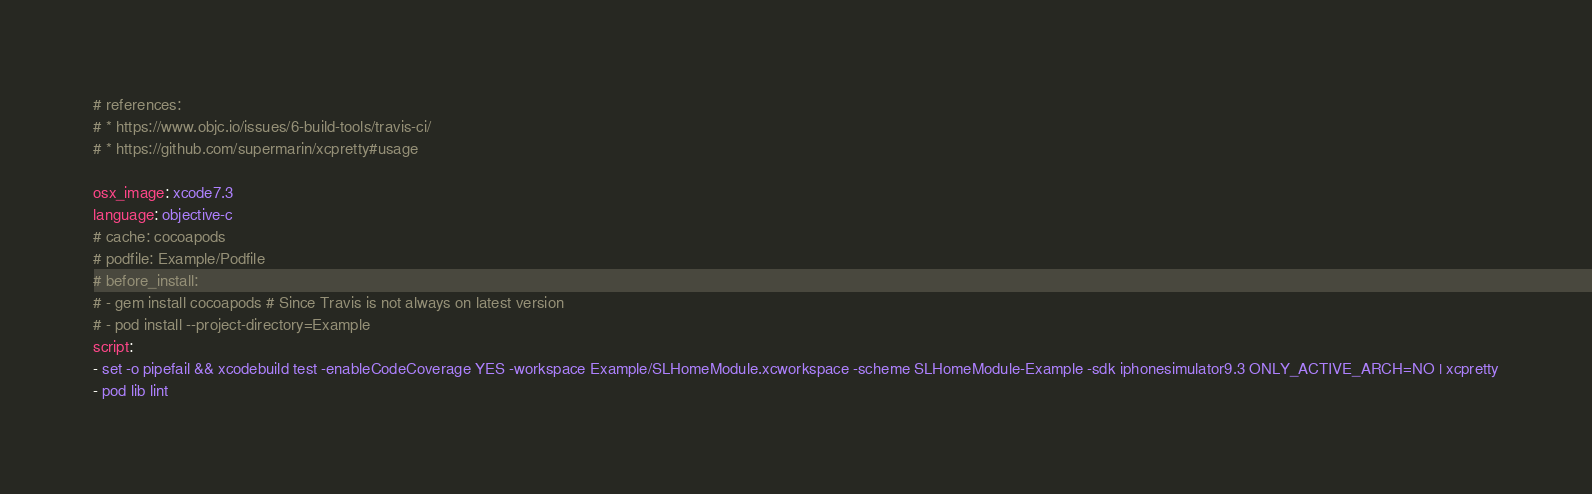<code> <loc_0><loc_0><loc_500><loc_500><_YAML_># references:
# * https://www.objc.io/issues/6-build-tools/travis-ci/
# * https://github.com/supermarin/xcpretty#usage

osx_image: xcode7.3
language: objective-c
# cache: cocoapods
# podfile: Example/Podfile
# before_install:
# - gem install cocoapods # Since Travis is not always on latest version
# - pod install --project-directory=Example
script:
- set -o pipefail && xcodebuild test -enableCodeCoverage YES -workspace Example/SLHomeModule.xcworkspace -scheme SLHomeModule-Example -sdk iphonesimulator9.3 ONLY_ACTIVE_ARCH=NO | xcpretty
- pod lib lint
</code> 